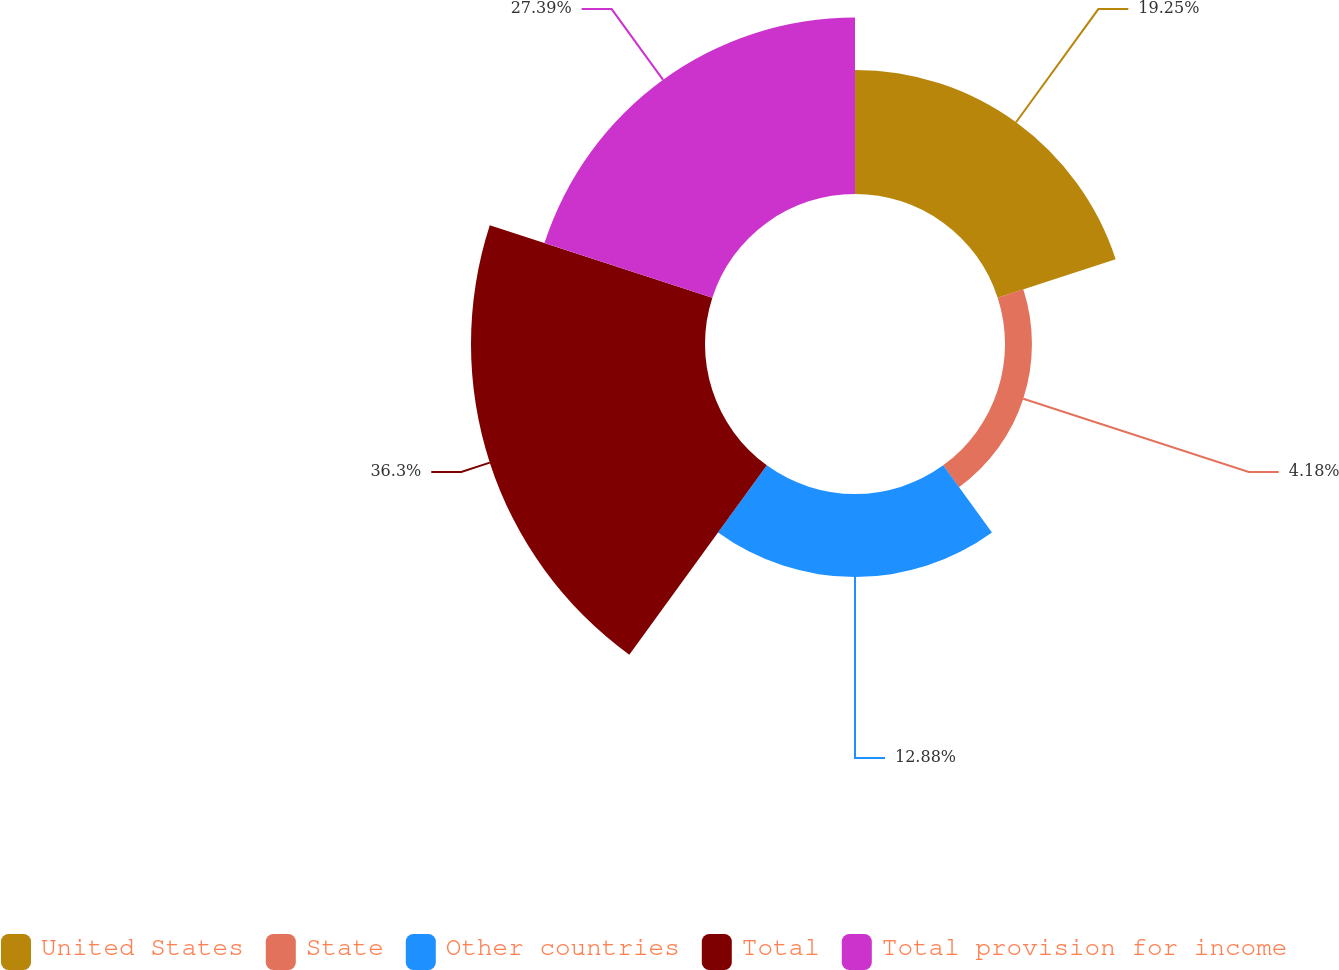<chart> <loc_0><loc_0><loc_500><loc_500><pie_chart><fcel>United States<fcel>State<fcel>Other countries<fcel>Total<fcel>Total provision for income<nl><fcel>19.25%<fcel>4.18%<fcel>12.88%<fcel>36.31%<fcel>27.39%<nl></chart> 